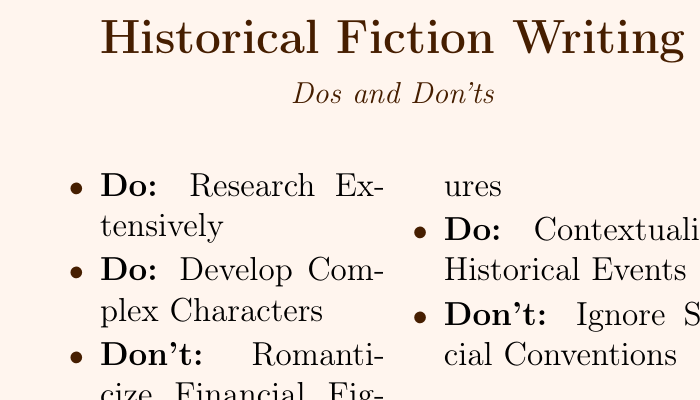What is the title on the front of the card? The title is prominently displayed at the top of the card and states the focus of the content.
Answer: Historical Fiction Writing Who is the author of the business card? The author's name is clearly indicated on the card, serving as the primary identity.
Answer: Alexandra Yates What is one of the dos listed on the card? The dos on the card provide guidance for writing historical fiction and show best practices.
Answer: Research Extensively What is one of the don'ts related to financial figures? The don'ts on the card highlight mistakes to avoid when writing historical fiction, particularly about financial topics.
Answer: Romanticize Financial Figures What is the author's website? The contact information listed helps connect readers with the author’s online presence.
Answer: www.alexandrayatesauthor.com What is the author's Twitter handle? The Twitter handle provides a way for readers to engage with the author on social media.
Answer: @HistorianAlex How many dos are listed on the card? The dos provide specific guidelines and are countable within the document.
Answer: 3 What does the author aim to achieve with their writing? The quote reflects the author's mission and purpose in writing historical fiction.
Answer: "Bringing the past to life, one story at a time." What color is used for the primary text on the card? The color choice for the text adds to the aesthetic of the business card.
Answer: RGB(70,30,0) 